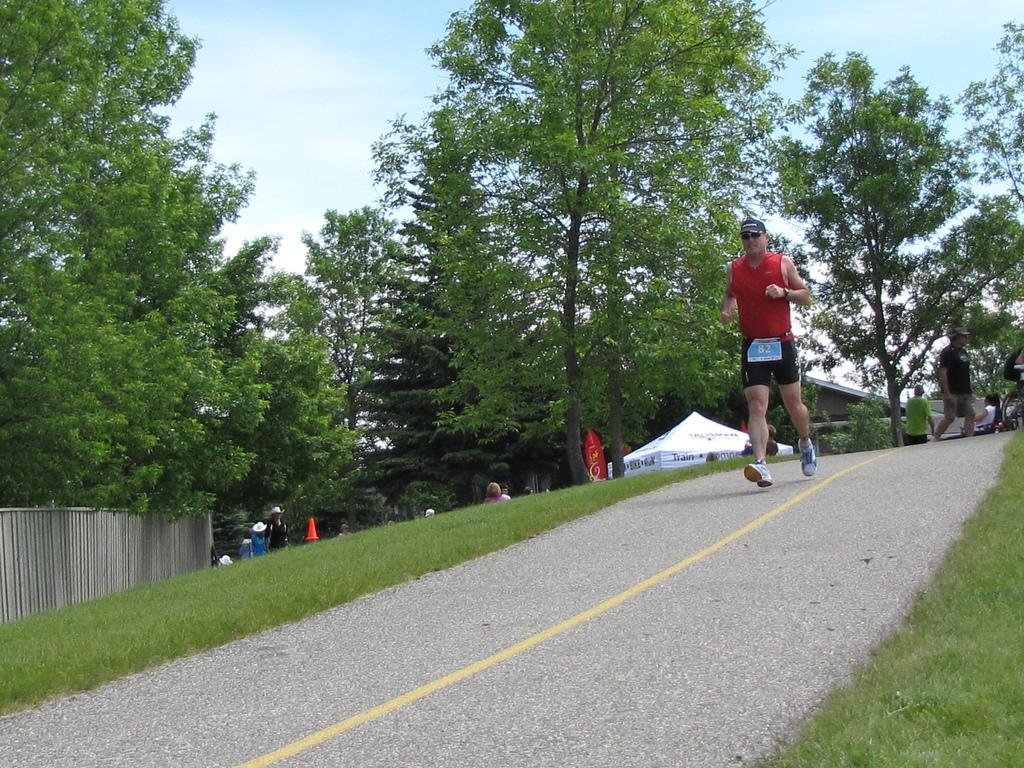What is the main subject of the image? There is a man in the image. What is the man doing in the image? The man is running on a path. What can be seen on the left side of the man? There is a wall on the left side of the man. Are there any other people visible in the image? Yes, there are people visible behind the man. What structures can be seen in the background of the image? There is a tent, a building, and trees in the background. What part of the natural environment is visible in the image? The sky is visible in the background. What type of army uniform is the man wearing in the image? The image does not show the man wearing any army uniform; he is simply running on a path. Can you tell me how many snakes are slithering on the sidewalk in the image? There are no snakes or sidewalks present in the image. 